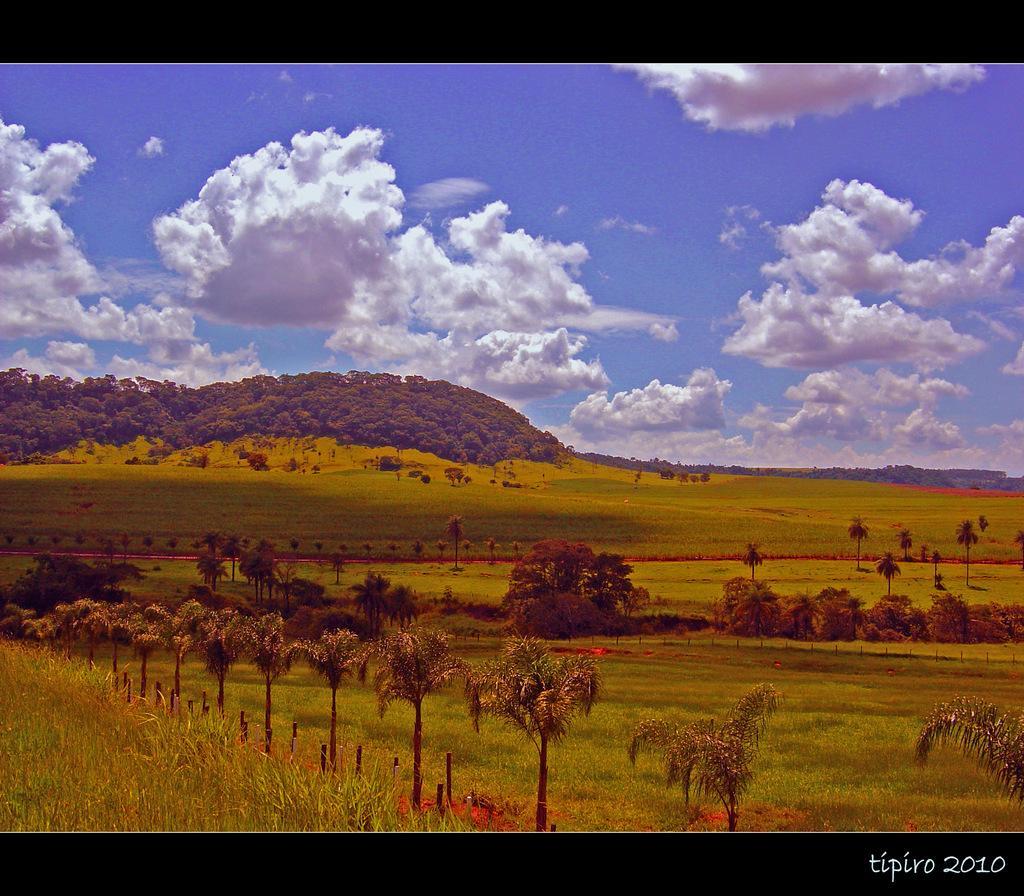Please provide a concise description of this image. In this image I can see an open grass ground and on it I can see number of trees. In the background I can see clouds, sky and here I can see watermark. 